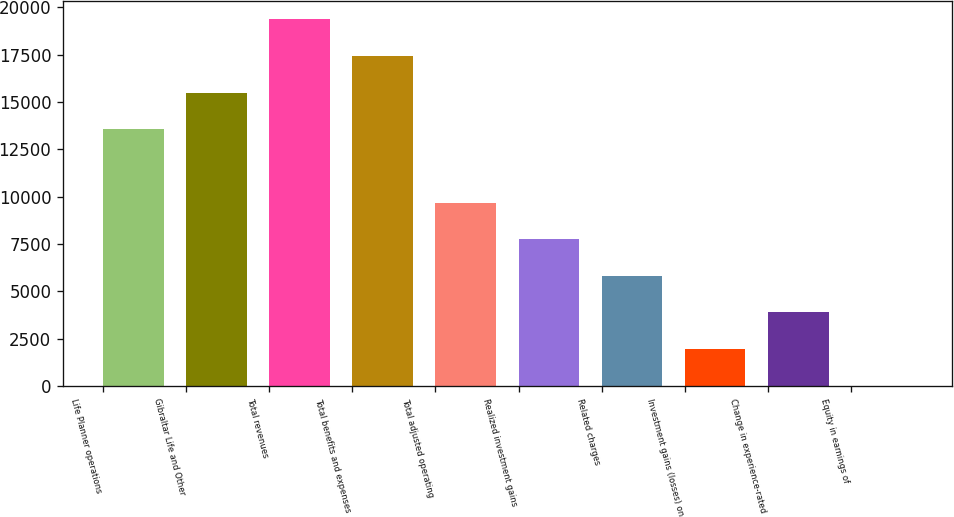Convert chart. <chart><loc_0><loc_0><loc_500><loc_500><bar_chart><fcel>Life Planner operations<fcel>Gibraltar Life and Other<fcel>Total revenues<fcel>Total benefits and expenses<fcel>Total adjusted operating<fcel>Realized investment gains<fcel>Related charges<fcel>Investment gains (losses) on<fcel>Change in experience-rated<fcel>Equity in earnings of<nl><fcel>13557.2<fcel>15492.8<fcel>19364<fcel>17428.4<fcel>9686<fcel>7750.4<fcel>5814.8<fcel>1943.6<fcel>3879.2<fcel>8<nl></chart> 